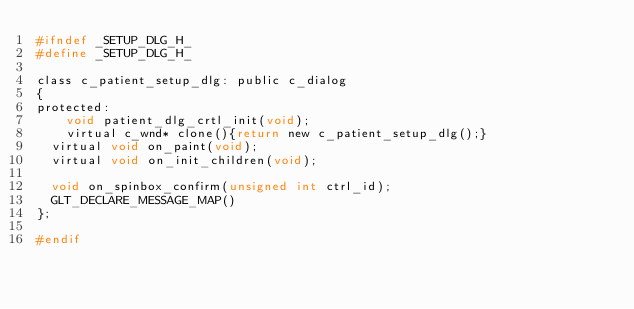<code> <loc_0><loc_0><loc_500><loc_500><_C_>#ifndef _SETUP_DLG_H_
#define _SETUP_DLG_H_

class c_patient_setup_dlg: public c_dialog
{
protected:
    void patient_dlg_crtl_init(void);
    virtual c_wnd* clone(){return new c_patient_setup_dlg();}
	virtual void on_paint(void);
	virtual void on_init_children(void);

	void on_spinbox_confirm(unsigned int ctrl_id);
	GLT_DECLARE_MESSAGE_MAP()
};

#endif
</code> 